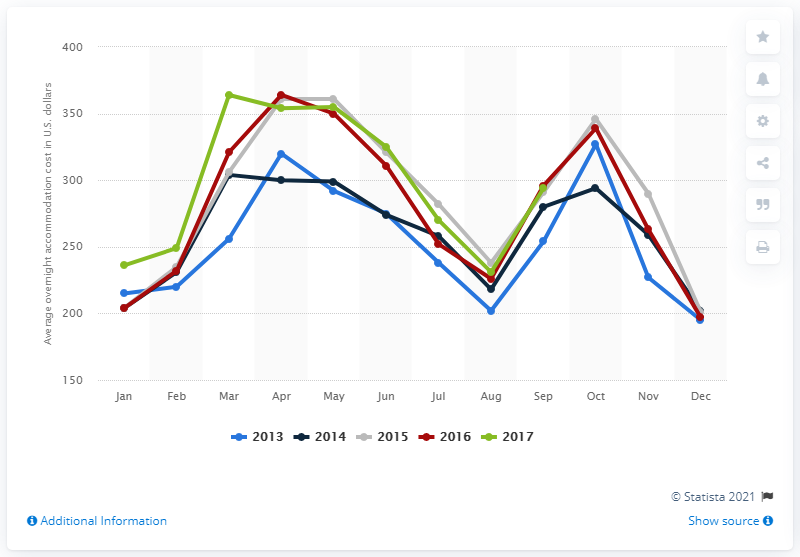Give some essential details in this illustration. In July 2017, the average cost of overnight accommodation in Washington D.C. was approximately $270. 